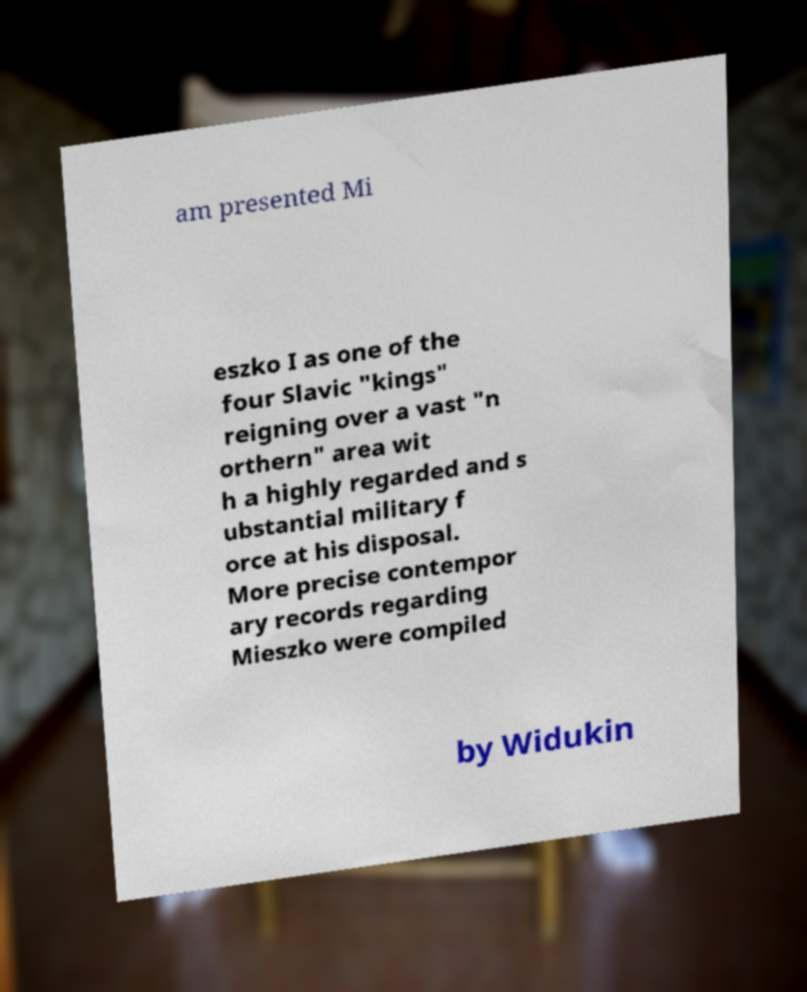Can you read and provide the text displayed in the image?This photo seems to have some interesting text. Can you extract and type it out for me? am presented Mi eszko I as one of the four Slavic "kings" reigning over a vast "n orthern" area wit h a highly regarded and s ubstantial military f orce at his disposal. More precise contempor ary records regarding Mieszko were compiled by Widukin 